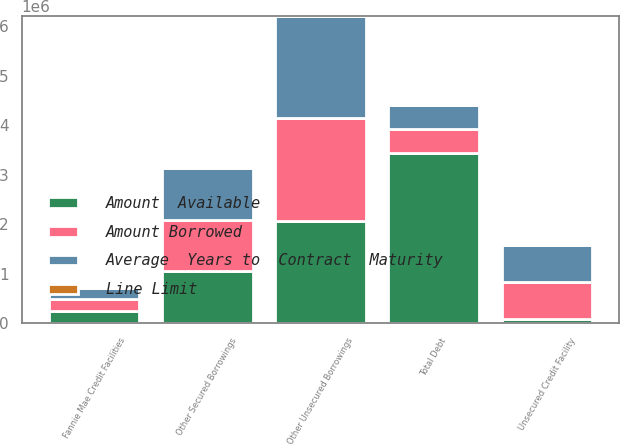Convert chart to OTSL. <chart><loc_0><loc_0><loc_500><loc_500><stacked_bar_chart><ecel><fcel>Fannie Mae Credit Facilities<fcel>Other Secured Borrowings<fcel>Unsecured Credit Facility<fcel>Other Unsecured Borrowings<fcel>Total Debt<nl><fcel>Average  Years to  Contract  Maturity<fcel>240000<fcel>1.04624e+06<fcel>750000<fcel>2.06633e+06<fcel>493361<nl><fcel>Amount Borrowed<fcel>240000<fcel>1.04624e+06<fcel>746722<fcel>2.06633e+06<fcel>493361<nl><fcel>Amount  Available<fcel>240000<fcel>1.04624e+06<fcel>75000<fcel>2.06633e+06<fcel>3.42757e+06<nl><fcel>Line Limit<fcel>1.6<fcel>3.5<fcel>4.3<fcel>6.1<fcel>5<nl></chart> 